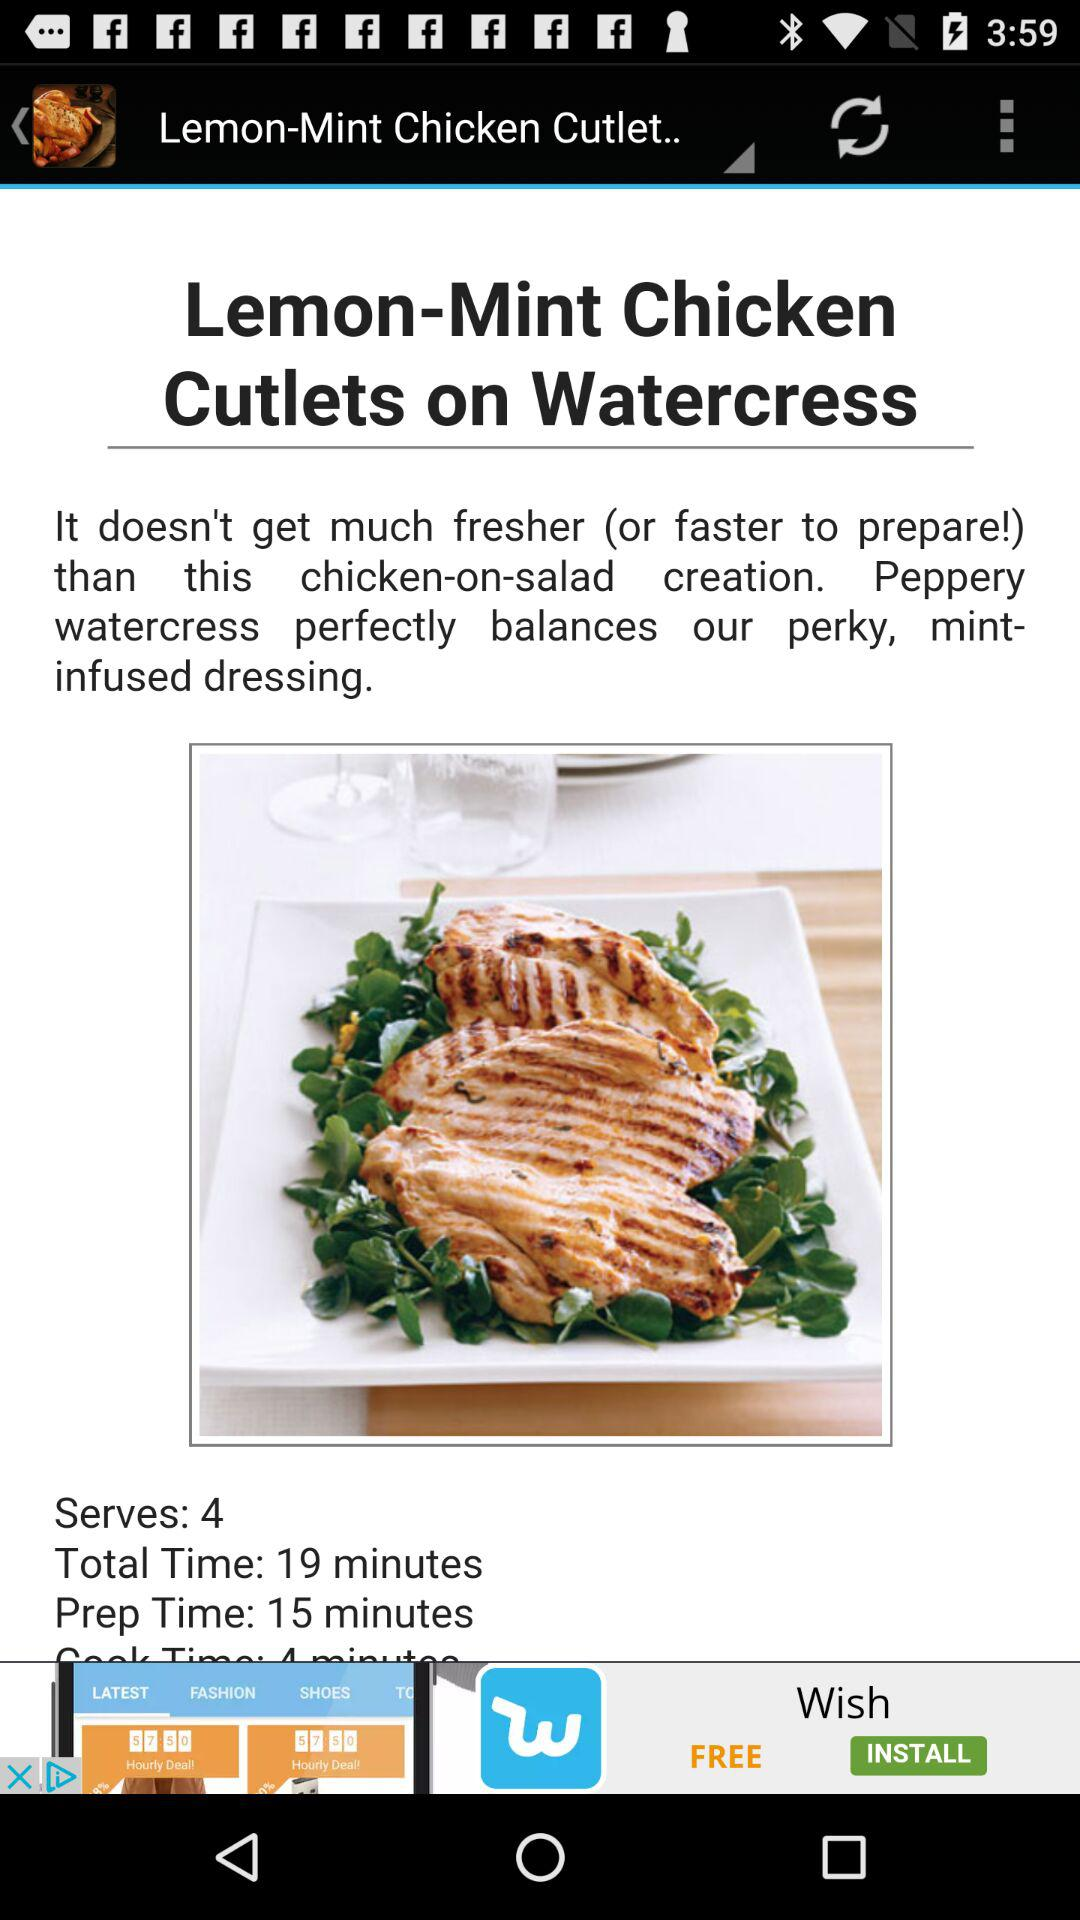How many calories are in "Lemon-Mint Chicken Cutlets on Watercress"?
When the provided information is insufficient, respond with <no answer>. <no answer> 